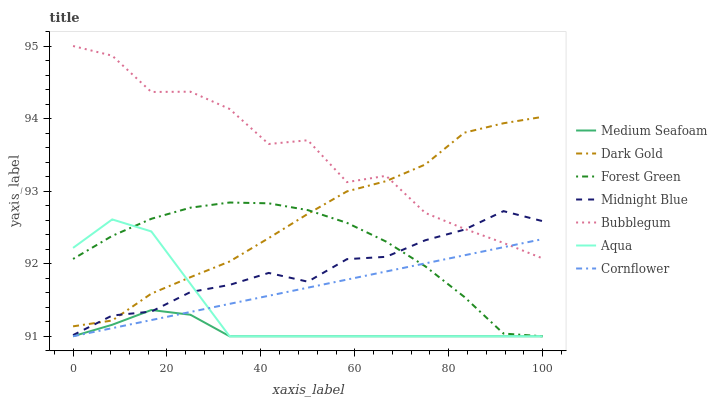Does Medium Seafoam have the minimum area under the curve?
Answer yes or no. Yes. Does Bubblegum have the maximum area under the curve?
Answer yes or no. Yes. Does Midnight Blue have the minimum area under the curve?
Answer yes or no. No. Does Midnight Blue have the maximum area under the curve?
Answer yes or no. No. Is Cornflower the smoothest?
Answer yes or no. Yes. Is Bubblegum the roughest?
Answer yes or no. Yes. Is Midnight Blue the smoothest?
Answer yes or no. No. Is Midnight Blue the roughest?
Answer yes or no. No. Does Cornflower have the lowest value?
Answer yes or no. Yes. Does Midnight Blue have the lowest value?
Answer yes or no. No. Does Bubblegum have the highest value?
Answer yes or no. Yes. Does Midnight Blue have the highest value?
Answer yes or no. No. Is Forest Green less than Bubblegum?
Answer yes or no. Yes. Is Bubblegum greater than Forest Green?
Answer yes or no. Yes. Does Dark Gold intersect Midnight Blue?
Answer yes or no. Yes. Is Dark Gold less than Midnight Blue?
Answer yes or no. No. Is Dark Gold greater than Midnight Blue?
Answer yes or no. No. Does Forest Green intersect Bubblegum?
Answer yes or no. No. 